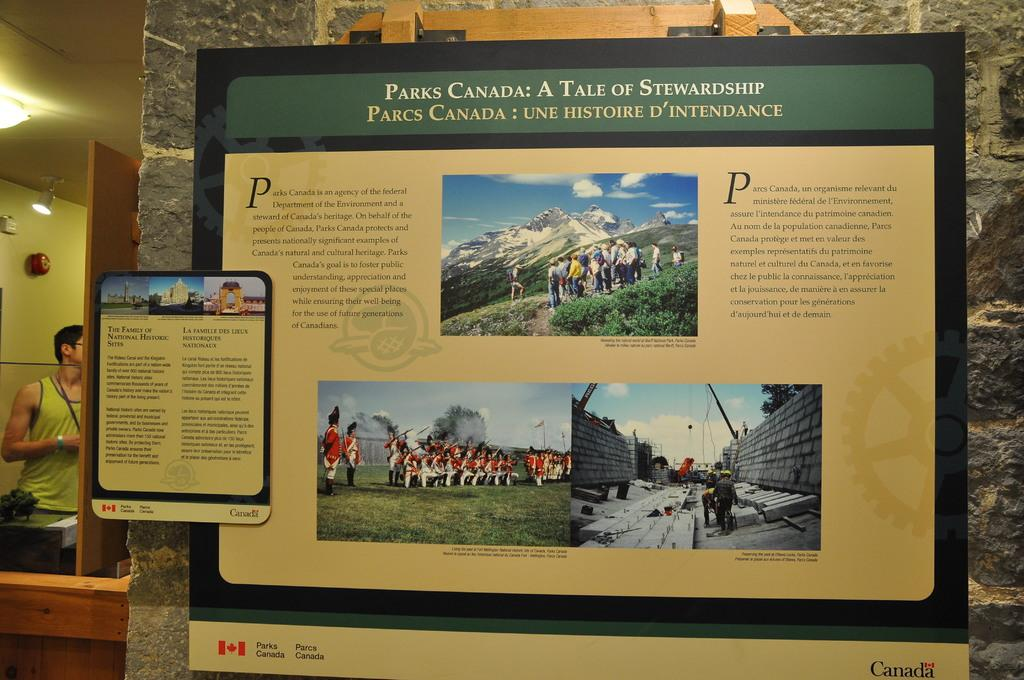<image>
Render a clear and concise summary of the photo. A sign that tells about the founding of parks in Canada. 